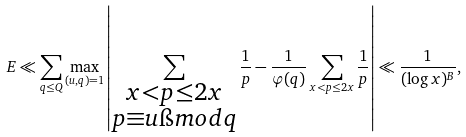Convert formula to latex. <formula><loc_0><loc_0><loc_500><loc_500>E \ll \sum _ { q \leq Q } \max _ { ( u , q ) = 1 } \left | \sum _ { \substack { x < p \leq 2 x \\ p \equiv u \i m o d { q } } } \frac { 1 } { p } - \frac { 1 } { \varphi ( q ) } \sum _ { x < p \leq 2 x } \frac { 1 } { p } \right | \ll \frac { 1 } { ( \log x ) ^ { B } } ,</formula> 